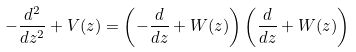Convert formula to latex. <formula><loc_0><loc_0><loc_500><loc_500>- \frac { d ^ { 2 } } { d z ^ { 2 } } + V ( z ) = \left ( - \frac { d } { d z } + W ( z ) \right ) \left ( \frac { d } { d z } + W ( z ) \right )</formula> 